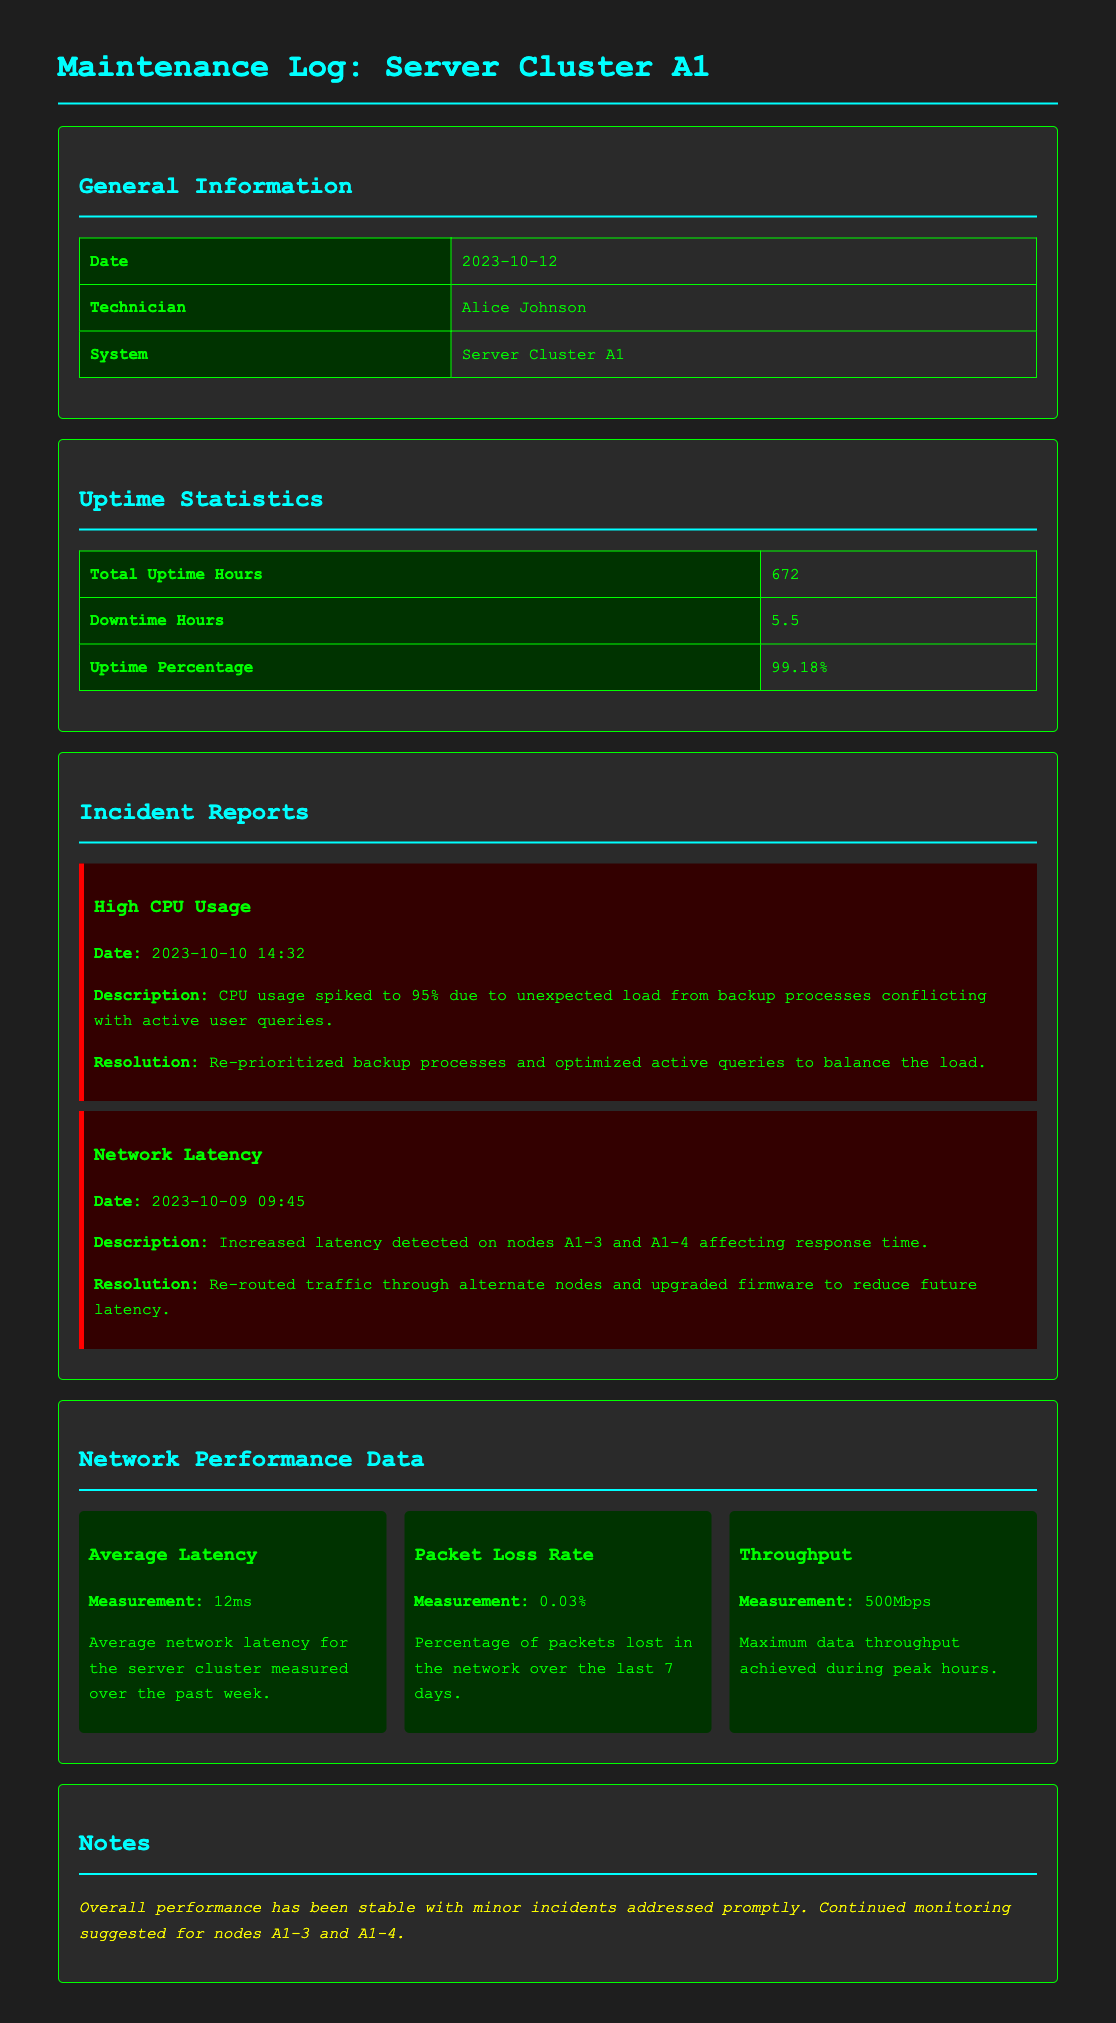What is the total uptime hours? The total uptime hours are listed in the uptime statistics section of the document.
Answer: 672 Who was the technician responsible for the maintenance? The technician's name is provided in the general information section.
Answer: Alice Johnson What was the uptime percentage? The uptime percentage can be found in the uptime statistics provided in the document.
Answer: 99.18% What was the high CPU usage date? The date of the high CPU usage incident is detailed in the incident reports section.
Answer: 2023-10-10 14:32 What action was taken for network latency? The resolution for the network latency incident indicates the steps taken as described in the document.
Answer: Re-routed traffic through alternate nodes and upgraded firmware What was the average latency measurement? The average latency measurement is included in the network performance data section.
Answer: 12ms How many downtime hours were recorded? The downtime hours are explicitly mentioned in the uptime statistics section of the document.
Answer: 5.5 What is the packet loss rate? The packet loss rate can be found in the network performance data metrics.
Answer: 0.03% What is suggested for nodes A1-3 and A1-4? The notes section includes recommendations regarding the monitoring of these nodes.
Answer: Continued monitoring 